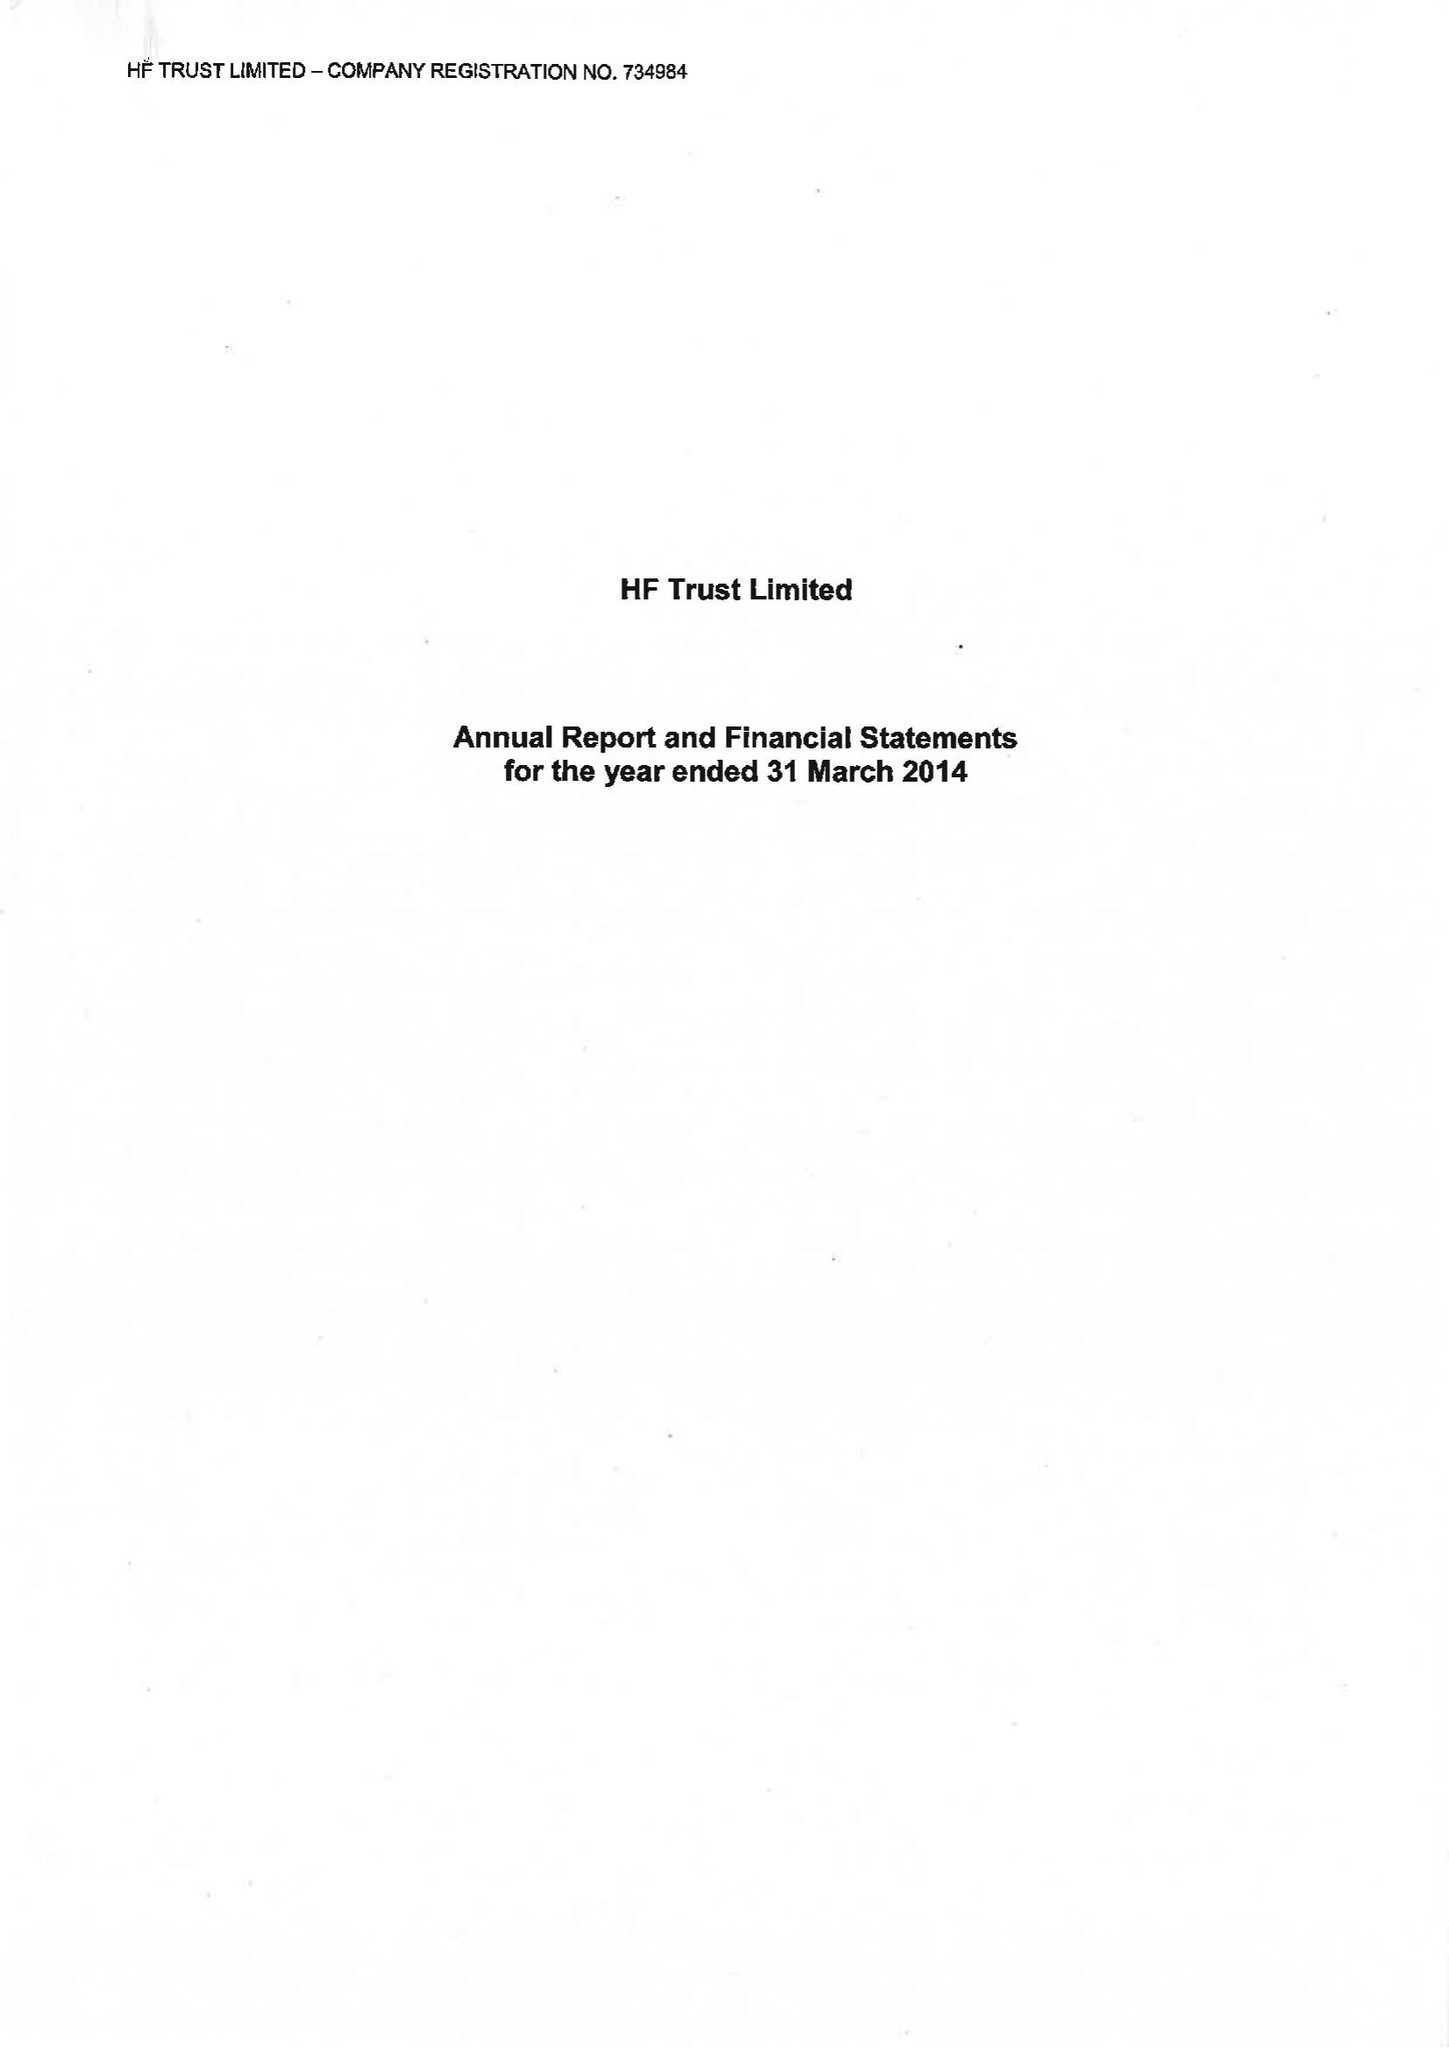What is the value for the spending_annually_in_british_pounds?
Answer the question using a single word or phrase. 70894000.00 